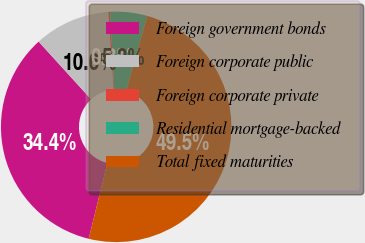Convert chart to OTSL. <chart><loc_0><loc_0><loc_500><loc_500><pie_chart><fcel>Foreign government bonds<fcel>Foreign corporate public<fcel>Foreign corporate private<fcel>Residential mortgage-backed<fcel>Total fixed maturities<nl><fcel>34.42%<fcel>10.65%<fcel>0.26%<fcel>5.18%<fcel>49.49%<nl></chart> 